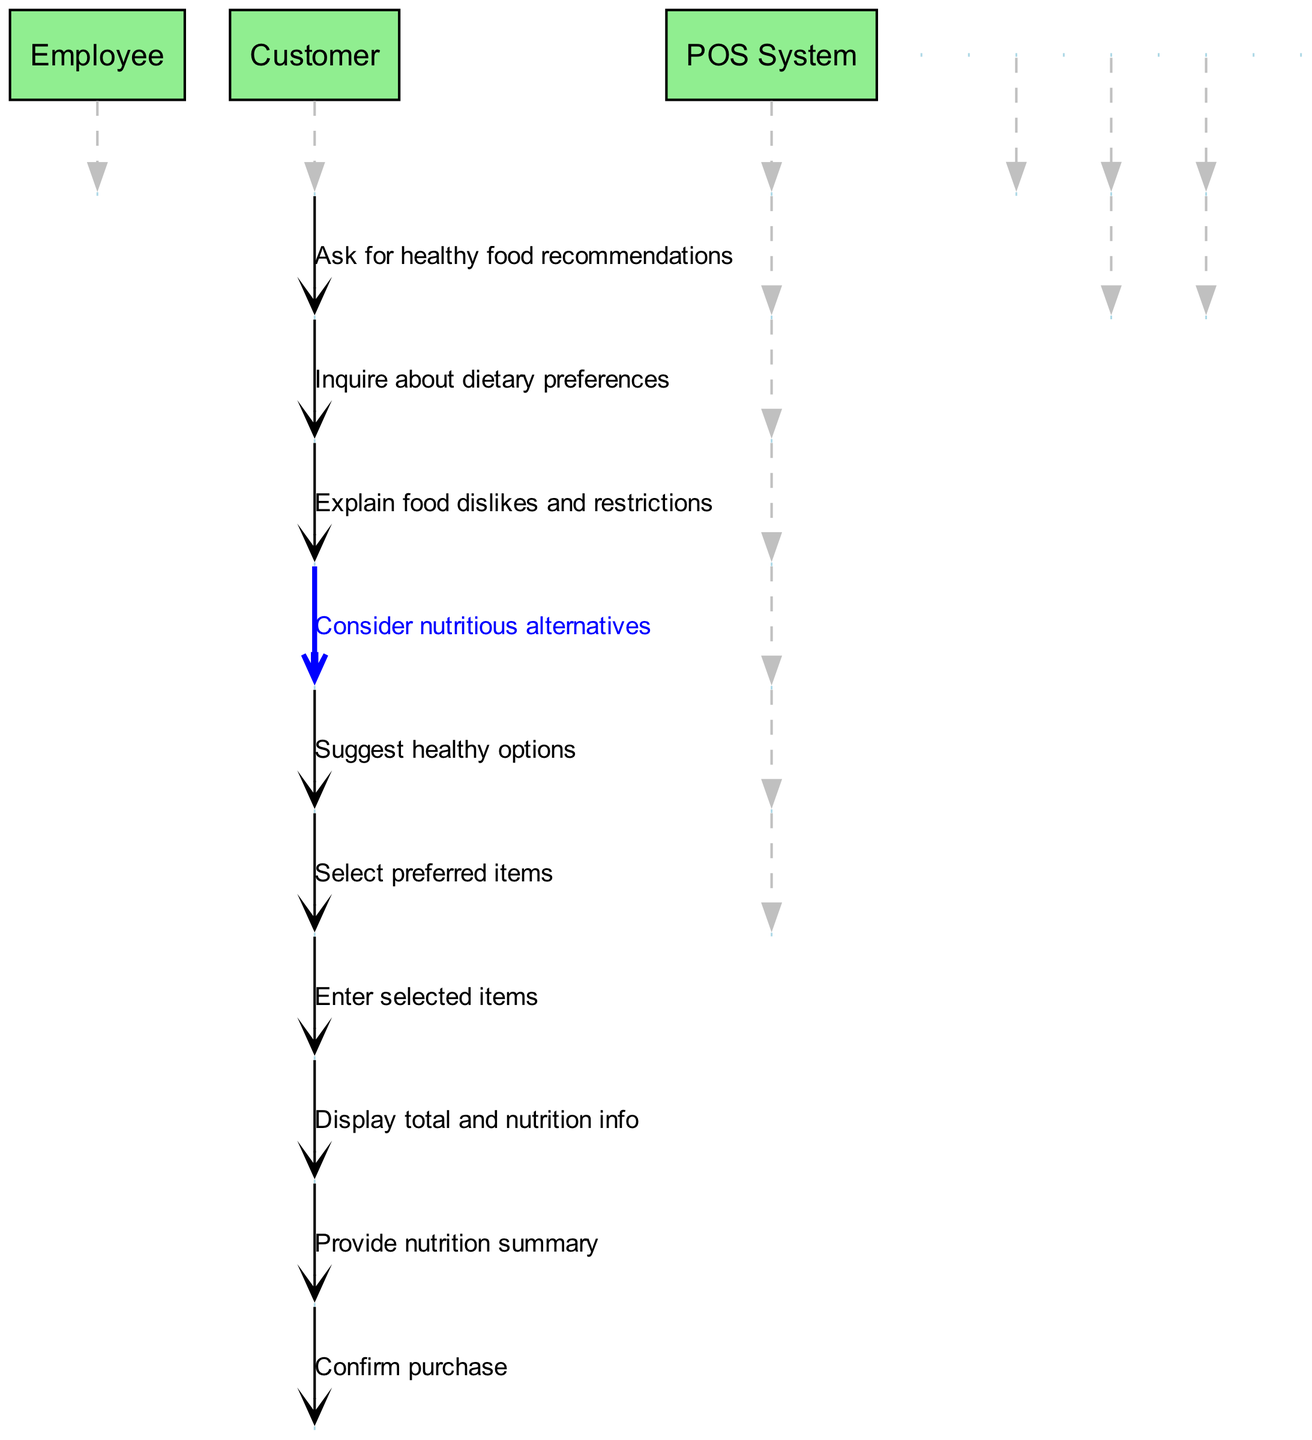What is the first interaction in the diagram? The first interaction starts with the Customer who asks the Employee for healthy food recommendations. This is indicated as the first message in the sequence.
Answer: Ask for healthy food recommendations How many actors are involved in the process? The diagram includes three actors: Employee, Customer, and POS System. By counting the unique actor nodes, we determine the total.
Answer: 3 What suggestion does the Employee make after considering alternatives? After considering nutritious alternatives, the Employee suggests healthy options to the Customer as the next message in the sequence.
Answer: Suggest healthy options Which actor enters selected items into the POS System? The Employee is the one who enters the selected items into the POS System, as shown in the sequence where the Employee sends this message to the POS System.
Answer: Employee What type of information does the POS System display? The POS System displays the total amount and nutrition info after receiving the entered items from the Employee. This information is explicitly stated in the message from the POS System to the Employee.
Answer: Total and nutrition info Which actor confirms the purchase? The Customer confirms the purchase as the final interaction in the sequence, indicating agreement to proceed with the selected items.
Answer: Customer What message precedes the confirmation of purchase? Before confirming the purchase, the Employee provides a nutrition summary to the Customer, which is the message right before the confirmation in the sequence.
Answer: Provide nutrition summary How many exchanges happen between the Customer and Employee? There are six exchanges between the Customer and Employee throughout the diagram as counted in the sequence.
Answer: 6 What is the purpose of the inquiry made by the Employee after the initial request? The purpose of the inquiry made by the Employee is to understand the Customer's dietary preferences, which is essential for giving tailored recommendations.
Answer: Inquire about dietary preferences 